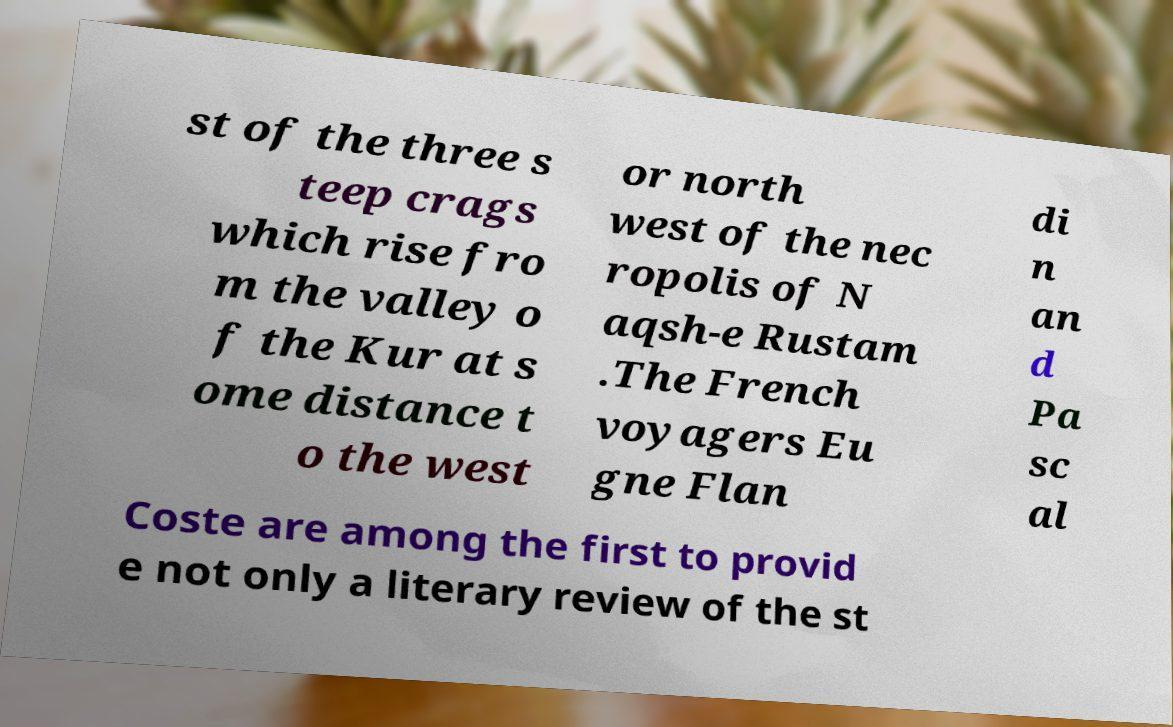Can you accurately transcribe the text from the provided image for me? st of the three s teep crags which rise fro m the valley o f the Kur at s ome distance t o the west or north west of the nec ropolis of N aqsh-e Rustam .The French voyagers Eu gne Flan di n an d Pa sc al Coste are among the first to provid e not only a literary review of the st 